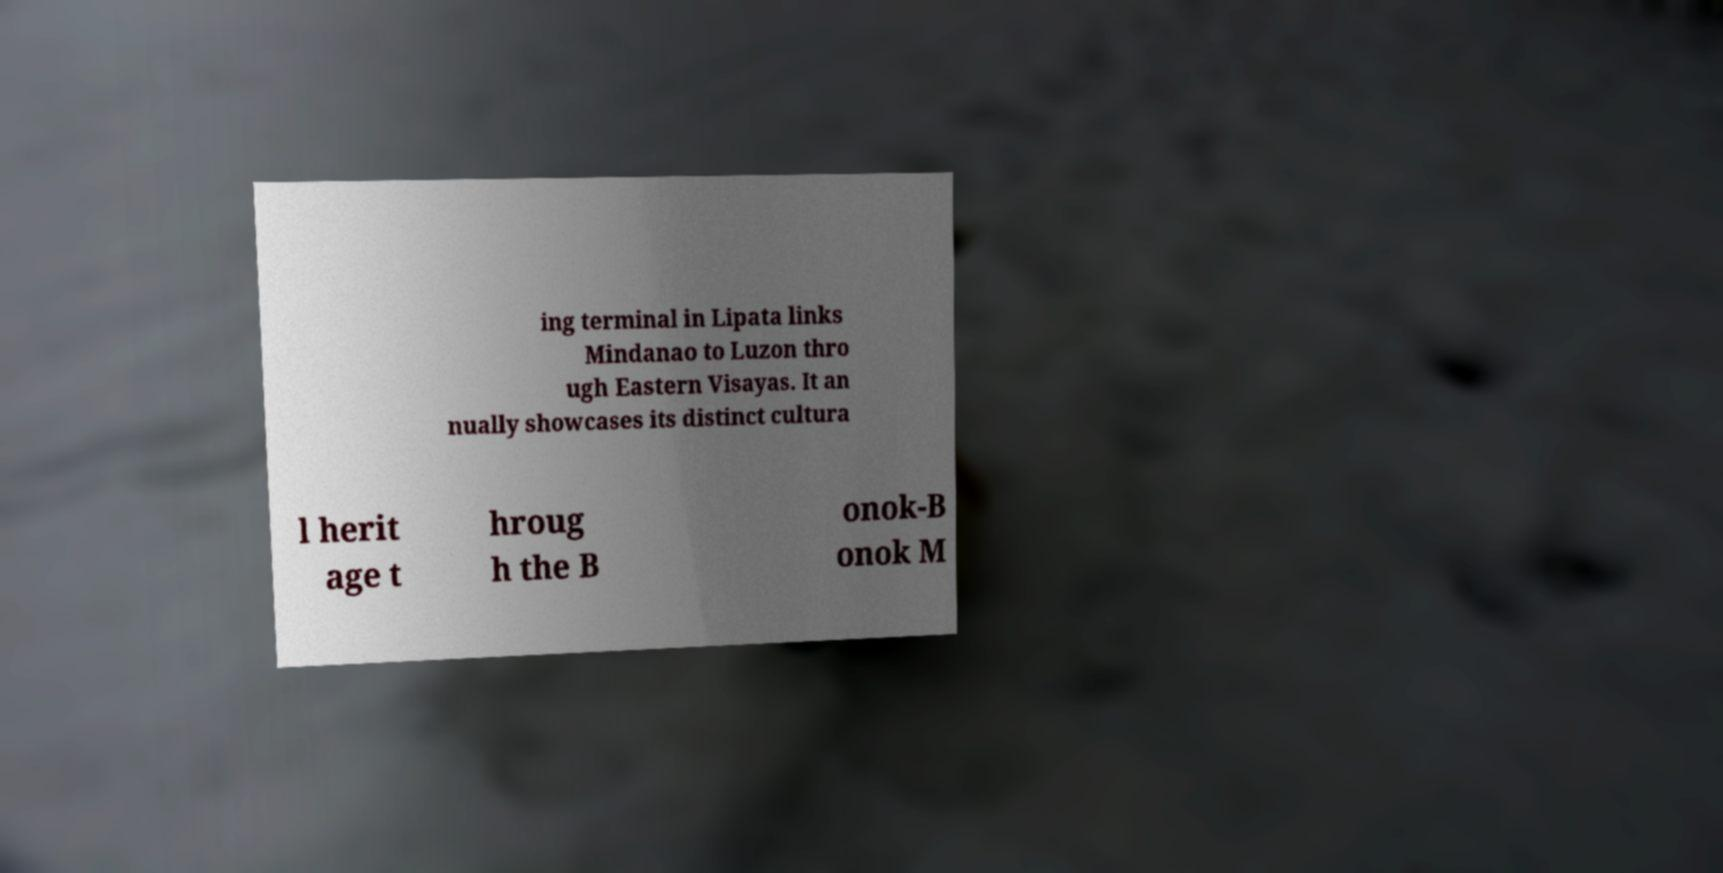For documentation purposes, I need the text within this image transcribed. Could you provide that? ing terminal in Lipata links Mindanao to Luzon thro ugh Eastern Visayas. It an nually showcases its distinct cultura l herit age t hroug h the B onok-B onok M 